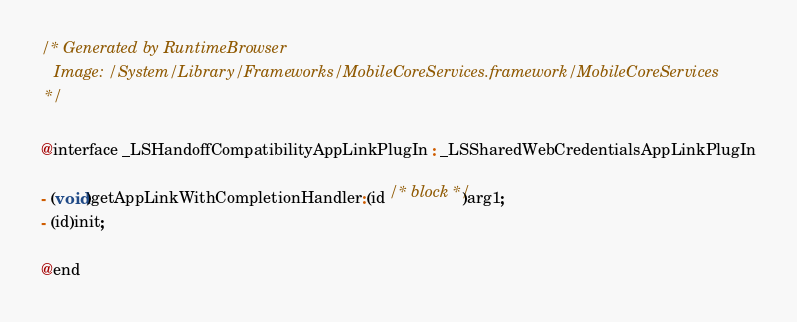<code> <loc_0><loc_0><loc_500><loc_500><_C_>/* Generated by RuntimeBrowser
   Image: /System/Library/Frameworks/MobileCoreServices.framework/MobileCoreServices
 */

@interface _LSHandoffCompatibilityAppLinkPlugIn : _LSSharedWebCredentialsAppLinkPlugIn

- (void)getAppLinkWithCompletionHandler:(id /* block */)arg1;
- (id)init;

@end
</code> 